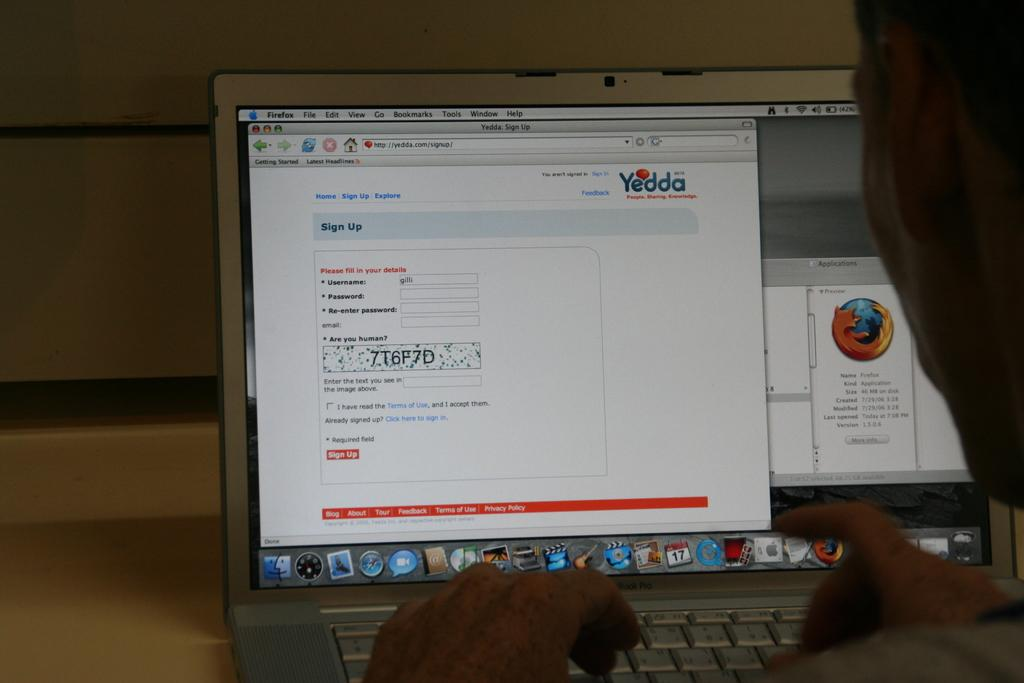<image>
Give a short and clear explanation of the subsequent image. A laptop is open and is displaying a firefox browser. 